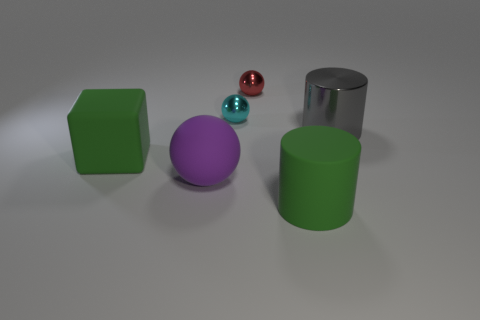Add 2 yellow rubber blocks. How many objects exist? 8 Subtract all blocks. How many objects are left? 5 Add 4 big gray metallic things. How many big gray metallic things are left? 5 Add 2 small green objects. How many small green objects exist? 2 Subtract 1 green cubes. How many objects are left? 5 Subtract all cyan cubes. Subtract all big rubber spheres. How many objects are left? 5 